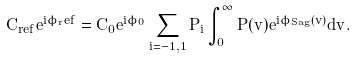<formula> <loc_0><loc_0><loc_500><loc_500>C _ { r e f } e ^ { i \phi _ { r } e f } = C _ { 0 } e ^ { i \phi _ { 0 } } \sum _ { i = - 1 , 1 } P _ { i } \int ^ { \infty } _ { 0 } P ( v ) e ^ { i \phi _ { S a g } ( v ) } d v .</formula> 